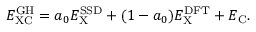<formula> <loc_0><loc_0><loc_500><loc_500>E _ { X C } ^ { G H } = a _ { 0 } E _ { X } ^ { S S D } + ( 1 - a _ { 0 } ) E _ { X } ^ { D F T } + E _ { C } .</formula> 